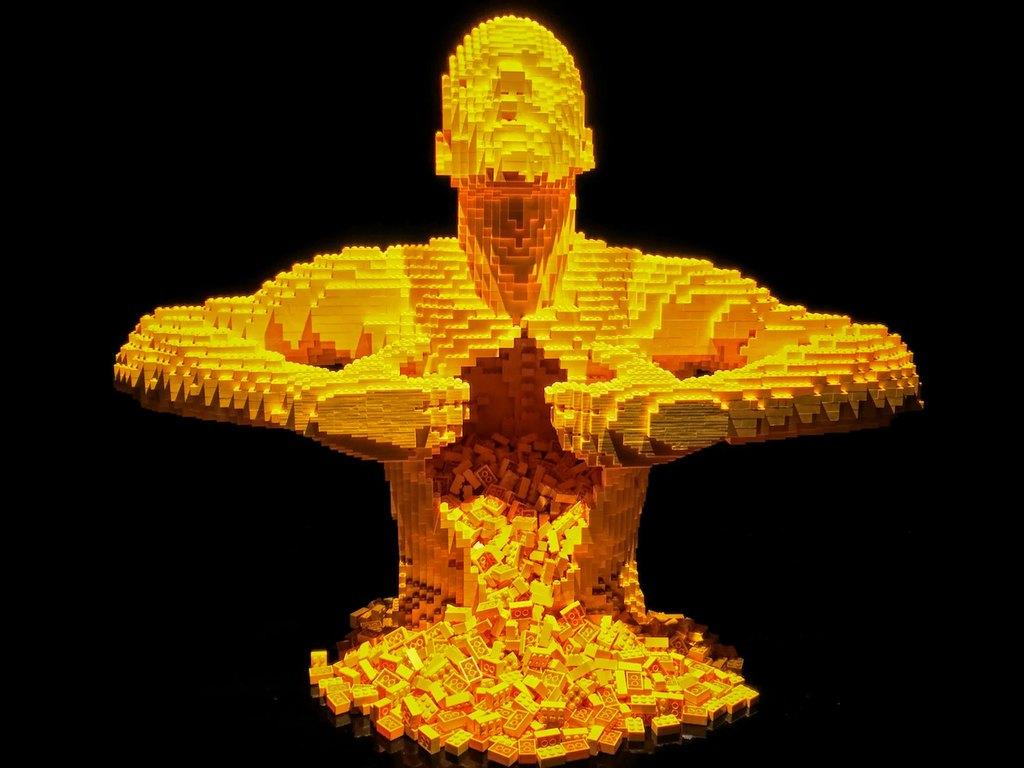What is the main subject of the image? The main subject of the image is a statue. What material is the statue made of? The statue is made with Lego blocks. What type of mint is growing around the statue in the image? There is no mint present in the image; the statue is made with Lego blocks. What color is the sweater worn by the statue in the image? There is no sweater present in the image, as the statue is made with Lego blocks and does not have clothing. 